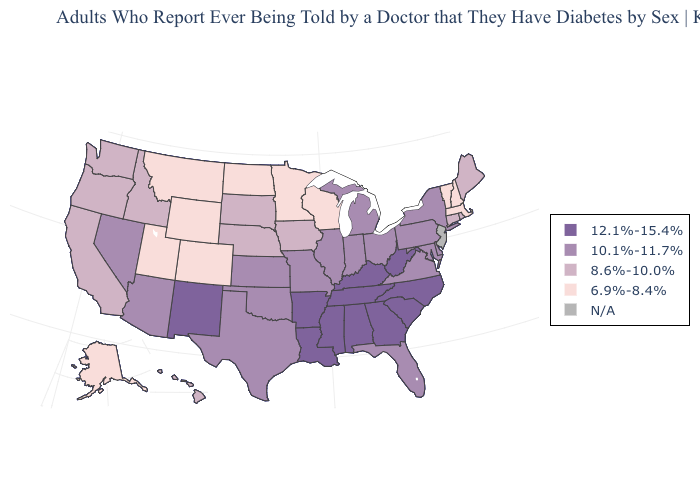What is the value of Wisconsin?
Keep it brief. 6.9%-8.4%. What is the highest value in states that border Montana?
Quick response, please. 8.6%-10.0%. Does the first symbol in the legend represent the smallest category?
Answer briefly. No. Does Maryland have the lowest value in the USA?
Give a very brief answer. No. Does Ohio have the lowest value in the USA?
Quick response, please. No. What is the lowest value in the USA?
Quick response, please. 6.9%-8.4%. Which states have the lowest value in the Northeast?
Answer briefly. Massachusetts, New Hampshire, Vermont. Does Hawaii have the highest value in the West?
Give a very brief answer. No. Which states hav the highest value in the West?
Give a very brief answer. New Mexico. What is the lowest value in the USA?
Quick response, please. 6.9%-8.4%. Name the states that have a value in the range 6.9%-8.4%?
Short answer required. Alaska, Colorado, Massachusetts, Minnesota, Montana, New Hampshire, North Dakota, Utah, Vermont, Wisconsin, Wyoming. What is the value of North Dakota?
Quick response, please. 6.9%-8.4%. What is the lowest value in the USA?
Quick response, please. 6.9%-8.4%. 